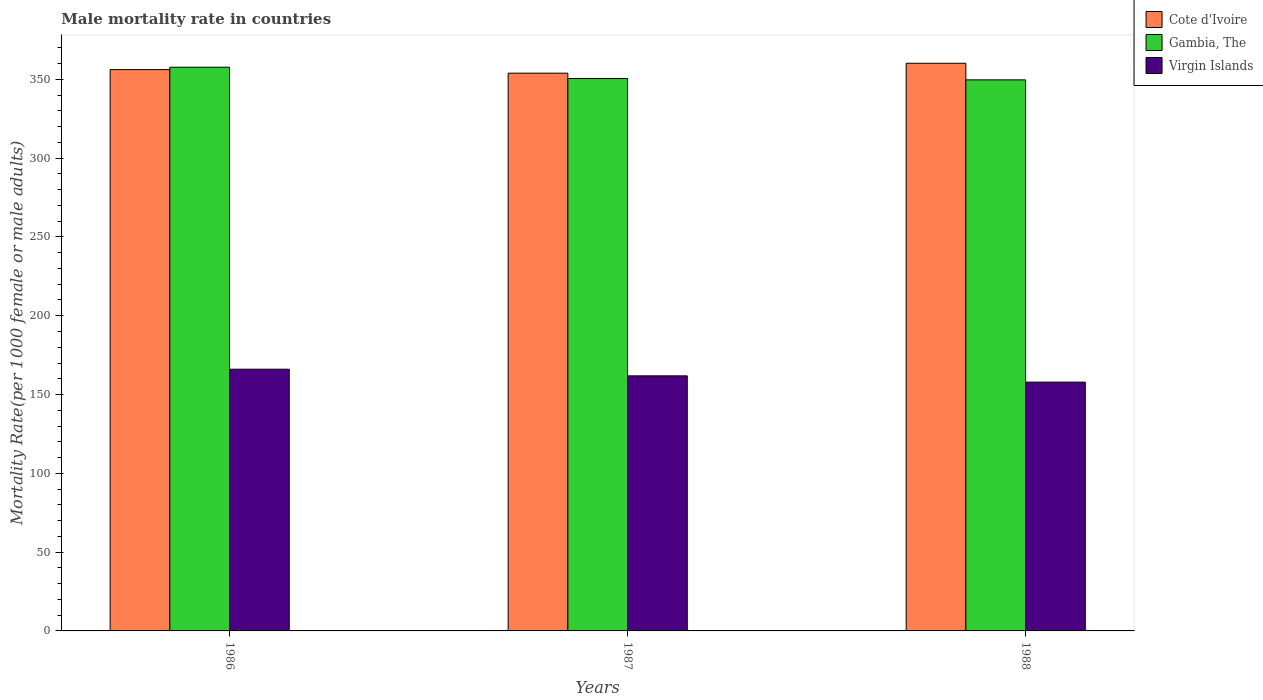How many different coloured bars are there?
Provide a succinct answer. 3. How many groups of bars are there?
Your answer should be very brief. 3. Are the number of bars per tick equal to the number of legend labels?
Your answer should be very brief. Yes. How many bars are there on the 2nd tick from the left?
Give a very brief answer. 3. What is the male mortality rate in Virgin Islands in 1988?
Make the answer very short. 157.87. Across all years, what is the maximum male mortality rate in Gambia, The?
Ensure brevity in your answer.  357.7. Across all years, what is the minimum male mortality rate in Cote d'Ivoire?
Provide a short and direct response. 353.91. What is the total male mortality rate in Gambia, The in the graph?
Provide a short and direct response. 1057.88. What is the difference between the male mortality rate in Cote d'Ivoire in 1986 and that in 1987?
Offer a very short reply. 2.27. What is the difference between the male mortality rate in Gambia, The in 1986 and the male mortality rate in Cote d'Ivoire in 1987?
Offer a very short reply. 3.79. What is the average male mortality rate in Gambia, The per year?
Your response must be concise. 352.63. In the year 1987, what is the difference between the male mortality rate in Gambia, The and male mortality rate in Cote d'Ivoire?
Your answer should be very brief. -3.39. What is the ratio of the male mortality rate in Virgin Islands in 1987 to that in 1988?
Your answer should be compact. 1.03. Is the difference between the male mortality rate in Gambia, The in 1987 and 1988 greater than the difference between the male mortality rate in Cote d'Ivoire in 1987 and 1988?
Give a very brief answer. Yes. What is the difference between the highest and the second highest male mortality rate in Virgin Islands?
Make the answer very short. 4.21. What is the difference between the highest and the lowest male mortality rate in Gambia, The?
Offer a terse response. 8.04. What does the 3rd bar from the left in 1988 represents?
Keep it short and to the point. Virgin Islands. What does the 3rd bar from the right in 1988 represents?
Offer a very short reply. Cote d'Ivoire. Is it the case that in every year, the sum of the male mortality rate in Gambia, The and male mortality rate in Cote d'Ivoire is greater than the male mortality rate in Virgin Islands?
Give a very brief answer. Yes. How many bars are there?
Offer a very short reply. 9. Are all the bars in the graph horizontal?
Offer a very short reply. No. How many years are there in the graph?
Your response must be concise. 3. What is the difference between two consecutive major ticks on the Y-axis?
Give a very brief answer. 50. Does the graph contain any zero values?
Provide a short and direct response. No. Where does the legend appear in the graph?
Offer a very short reply. Top right. How many legend labels are there?
Keep it short and to the point. 3. How are the legend labels stacked?
Your response must be concise. Vertical. What is the title of the graph?
Offer a very short reply. Male mortality rate in countries. What is the label or title of the Y-axis?
Keep it short and to the point. Mortality Rate(per 1000 female or male adults). What is the Mortality Rate(per 1000 female or male adults) of Cote d'Ivoire in 1986?
Ensure brevity in your answer.  356.18. What is the Mortality Rate(per 1000 female or male adults) of Gambia, The in 1986?
Provide a short and direct response. 357.7. What is the Mortality Rate(per 1000 female or male adults) of Virgin Islands in 1986?
Ensure brevity in your answer.  166.07. What is the Mortality Rate(per 1000 female or male adults) of Cote d'Ivoire in 1987?
Ensure brevity in your answer.  353.91. What is the Mortality Rate(per 1000 female or male adults) in Gambia, The in 1987?
Your answer should be very brief. 350.52. What is the Mortality Rate(per 1000 female or male adults) of Virgin Islands in 1987?
Your answer should be very brief. 161.85. What is the Mortality Rate(per 1000 female or male adults) of Cote d'Ivoire in 1988?
Offer a terse response. 360.2. What is the Mortality Rate(per 1000 female or male adults) in Gambia, The in 1988?
Provide a succinct answer. 349.66. What is the Mortality Rate(per 1000 female or male adults) of Virgin Islands in 1988?
Your response must be concise. 157.87. Across all years, what is the maximum Mortality Rate(per 1000 female or male adults) in Cote d'Ivoire?
Offer a very short reply. 360.2. Across all years, what is the maximum Mortality Rate(per 1000 female or male adults) of Gambia, The?
Keep it short and to the point. 357.7. Across all years, what is the maximum Mortality Rate(per 1000 female or male adults) of Virgin Islands?
Your response must be concise. 166.07. Across all years, what is the minimum Mortality Rate(per 1000 female or male adults) of Cote d'Ivoire?
Offer a very short reply. 353.91. Across all years, what is the minimum Mortality Rate(per 1000 female or male adults) of Gambia, The?
Offer a terse response. 349.66. Across all years, what is the minimum Mortality Rate(per 1000 female or male adults) of Virgin Islands?
Provide a succinct answer. 157.87. What is the total Mortality Rate(per 1000 female or male adults) of Cote d'Ivoire in the graph?
Provide a succinct answer. 1070.29. What is the total Mortality Rate(per 1000 female or male adults) of Gambia, The in the graph?
Your answer should be compact. 1057.88. What is the total Mortality Rate(per 1000 female or male adults) of Virgin Islands in the graph?
Your answer should be compact. 485.79. What is the difference between the Mortality Rate(per 1000 female or male adults) in Cote d'Ivoire in 1986 and that in 1987?
Provide a short and direct response. 2.27. What is the difference between the Mortality Rate(per 1000 female or male adults) in Gambia, The in 1986 and that in 1987?
Your response must be concise. 7.18. What is the difference between the Mortality Rate(per 1000 female or male adults) of Virgin Islands in 1986 and that in 1987?
Your answer should be very brief. 4.21. What is the difference between the Mortality Rate(per 1000 female or male adults) of Cote d'Ivoire in 1986 and that in 1988?
Provide a short and direct response. -4.03. What is the difference between the Mortality Rate(per 1000 female or male adults) in Gambia, The in 1986 and that in 1988?
Offer a very short reply. 8.04. What is the difference between the Mortality Rate(per 1000 female or male adults) of Virgin Islands in 1986 and that in 1988?
Ensure brevity in your answer.  8.2. What is the difference between the Mortality Rate(per 1000 female or male adults) in Cote d'Ivoire in 1987 and that in 1988?
Provide a succinct answer. -6.3. What is the difference between the Mortality Rate(per 1000 female or male adults) of Gambia, The in 1987 and that in 1988?
Make the answer very short. 0.86. What is the difference between the Mortality Rate(per 1000 female or male adults) of Virgin Islands in 1987 and that in 1988?
Offer a terse response. 3.98. What is the difference between the Mortality Rate(per 1000 female or male adults) in Cote d'Ivoire in 1986 and the Mortality Rate(per 1000 female or male adults) in Gambia, The in 1987?
Offer a very short reply. 5.66. What is the difference between the Mortality Rate(per 1000 female or male adults) of Cote d'Ivoire in 1986 and the Mortality Rate(per 1000 female or male adults) of Virgin Islands in 1987?
Provide a succinct answer. 194.32. What is the difference between the Mortality Rate(per 1000 female or male adults) in Gambia, The in 1986 and the Mortality Rate(per 1000 female or male adults) in Virgin Islands in 1987?
Ensure brevity in your answer.  195.84. What is the difference between the Mortality Rate(per 1000 female or male adults) in Cote d'Ivoire in 1986 and the Mortality Rate(per 1000 female or male adults) in Gambia, The in 1988?
Make the answer very short. 6.52. What is the difference between the Mortality Rate(per 1000 female or male adults) in Cote d'Ivoire in 1986 and the Mortality Rate(per 1000 female or male adults) in Virgin Islands in 1988?
Ensure brevity in your answer.  198.31. What is the difference between the Mortality Rate(per 1000 female or male adults) of Gambia, The in 1986 and the Mortality Rate(per 1000 female or male adults) of Virgin Islands in 1988?
Give a very brief answer. 199.83. What is the difference between the Mortality Rate(per 1000 female or male adults) of Cote d'Ivoire in 1987 and the Mortality Rate(per 1000 female or male adults) of Gambia, The in 1988?
Offer a terse response. 4.25. What is the difference between the Mortality Rate(per 1000 female or male adults) of Cote d'Ivoire in 1987 and the Mortality Rate(per 1000 female or male adults) of Virgin Islands in 1988?
Make the answer very short. 196.04. What is the difference between the Mortality Rate(per 1000 female or male adults) of Gambia, The in 1987 and the Mortality Rate(per 1000 female or male adults) of Virgin Islands in 1988?
Your answer should be very brief. 192.65. What is the average Mortality Rate(per 1000 female or male adults) in Cote d'Ivoire per year?
Your answer should be compact. 356.76. What is the average Mortality Rate(per 1000 female or male adults) in Gambia, The per year?
Offer a terse response. 352.63. What is the average Mortality Rate(per 1000 female or male adults) in Virgin Islands per year?
Your answer should be compact. 161.93. In the year 1986, what is the difference between the Mortality Rate(per 1000 female or male adults) in Cote d'Ivoire and Mortality Rate(per 1000 female or male adults) in Gambia, The?
Your answer should be very brief. -1.52. In the year 1986, what is the difference between the Mortality Rate(per 1000 female or male adults) of Cote d'Ivoire and Mortality Rate(per 1000 female or male adults) of Virgin Islands?
Offer a very short reply. 190.11. In the year 1986, what is the difference between the Mortality Rate(per 1000 female or male adults) in Gambia, The and Mortality Rate(per 1000 female or male adults) in Virgin Islands?
Provide a succinct answer. 191.63. In the year 1987, what is the difference between the Mortality Rate(per 1000 female or male adults) in Cote d'Ivoire and Mortality Rate(per 1000 female or male adults) in Gambia, The?
Make the answer very short. 3.39. In the year 1987, what is the difference between the Mortality Rate(per 1000 female or male adults) of Cote d'Ivoire and Mortality Rate(per 1000 female or male adults) of Virgin Islands?
Your response must be concise. 192.05. In the year 1987, what is the difference between the Mortality Rate(per 1000 female or male adults) in Gambia, The and Mortality Rate(per 1000 female or male adults) in Virgin Islands?
Offer a very short reply. 188.67. In the year 1988, what is the difference between the Mortality Rate(per 1000 female or male adults) of Cote d'Ivoire and Mortality Rate(per 1000 female or male adults) of Gambia, The?
Your answer should be very brief. 10.54. In the year 1988, what is the difference between the Mortality Rate(per 1000 female or male adults) in Cote d'Ivoire and Mortality Rate(per 1000 female or male adults) in Virgin Islands?
Make the answer very short. 202.33. In the year 1988, what is the difference between the Mortality Rate(per 1000 female or male adults) in Gambia, The and Mortality Rate(per 1000 female or male adults) in Virgin Islands?
Your answer should be very brief. 191.79. What is the ratio of the Mortality Rate(per 1000 female or male adults) of Cote d'Ivoire in 1986 to that in 1987?
Offer a very short reply. 1.01. What is the ratio of the Mortality Rate(per 1000 female or male adults) of Gambia, The in 1986 to that in 1987?
Provide a short and direct response. 1.02. What is the ratio of the Mortality Rate(per 1000 female or male adults) of Virgin Islands in 1986 to that in 1987?
Your answer should be very brief. 1.03. What is the ratio of the Mortality Rate(per 1000 female or male adults) of Virgin Islands in 1986 to that in 1988?
Offer a terse response. 1.05. What is the ratio of the Mortality Rate(per 1000 female or male adults) in Cote d'Ivoire in 1987 to that in 1988?
Provide a succinct answer. 0.98. What is the ratio of the Mortality Rate(per 1000 female or male adults) of Virgin Islands in 1987 to that in 1988?
Make the answer very short. 1.03. What is the difference between the highest and the second highest Mortality Rate(per 1000 female or male adults) in Cote d'Ivoire?
Give a very brief answer. 4.03. What is the difference between the highest and the second highest Mortality Rate(per 1000 female or male adults) of Gambia, The?
Provide a succinct answer. 7.18. What is the difference between the highest and the second highest Mortality Rate(per 1000 female or male adults) of Virgin Islands?
Your answer should be very brief. 4.21. What is the difference between the highest and the lowest Mortality Rate(per 1000 female or male adults) of Cote d'Ivoire?
Offer a terse response. 6.3. What is the difference between the highest and the lowest Mortality Rate(per 1000 female or male adults) in Gambia, The?
Give a very brief answer. 8.04. What is the difference between the highest and the lowest Mortality Rate(per 1000 female or male adults) of Virgin Islands?
Provide a short and direct response. 8.2. 